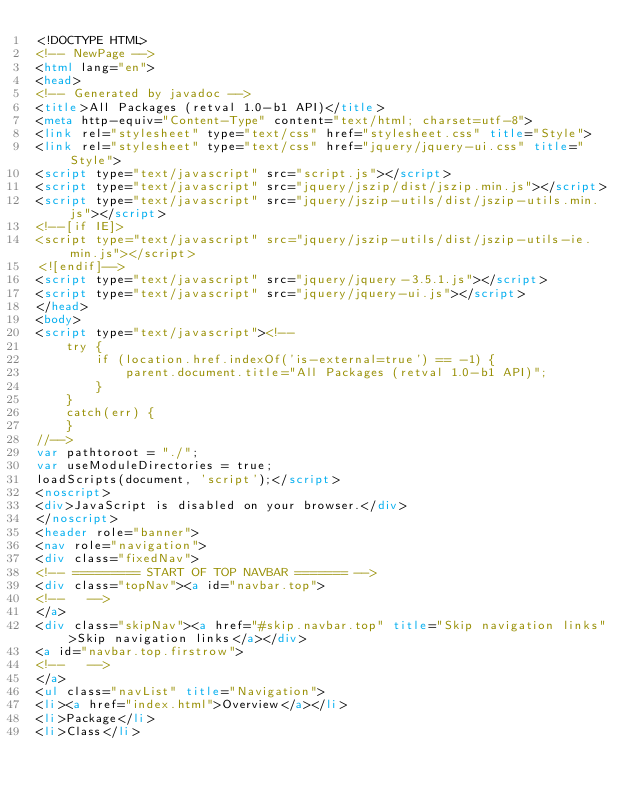<code> <loc_0><loc_0><loc_500><loc_500><_HTML_><!DOCTYPE HTML>
<!-- NewPage -->
<html lang="en">
<head>
<!-- Generated by javadoc -->
<title>All Packages (retval 1.0-b1 API)</title>
<meta http-equiv="Content-Type" content="text/html; charset=utf-8">
<link rel="stylesheet" type="text/css" href="stylesheet.css" title="Style">
<link rel="stylesheet" type="text/css" href="jquery/jquery-ui.css" title="Style">
<script type="text/javascript" src="script.js"></script>
<script type="text/javascript" src="jquery/jszip/dist/jszip.min.js"></script>
<script type="text/javascript" src="jquery/jszip-utils/dist/jszip-utils.min.js"></script>
<!--[if IE]>
<script type="text/javascript" src="jquery/jszip-utils/dist/jszip-utils-ie.min.js"></script>
<![endif]-->
<script type="text/javascript" src="jquery/jquery-3.5.1.js"></script>
<script type="text/javascript" src="jquery/jquery-ui.js"></script>
</head>
<body>
<script type="text/javascript"><!--
    try {
        if (location.href.indexOf('is-external=true') == -1) {
            parent.document.title="All Packages (retval 1.0-b1 API)";
        }
    }
    catch(err) {
    }
//-->
var pathtoroot = "./";
var useModuleDirectories = true;
loadScripts(document, 'script');</script>
<noscript>
<div>JavaScript is disabled on your browser.</div>
</noscript>
<header role="banner">
<nav role="navigation">
<div class="fixedNav">
<!-- ========= START OF TOP NAVBAR ======= -->
<div class="topNav"><a id="navbar.top">
<!--   -->
</a>
<div class="skipNav"><a href="#skip.navbar.top" title="Skip navigation links">Skip navigation links</a></div>
<a id="navbar.top.firstrow">
<!--   -->
</a>
<ul class="navList" title="Navigation">
<li><a href="index.html">Overview</a></li>
<li>Package</li>
<li>Class</li></code> 